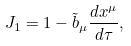Convert formula to latex. <formula><loc_0><loc_0><loc_500><loc_500>J _ { 1 } = 1 - \tilde { b } _ { \mu } \frac { d x ^ { \mu } } { d \tau } ,</formula> 